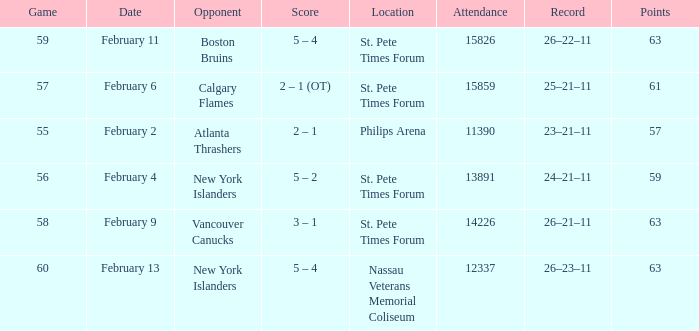What scores happened to be on February 9? 3 – 1. 